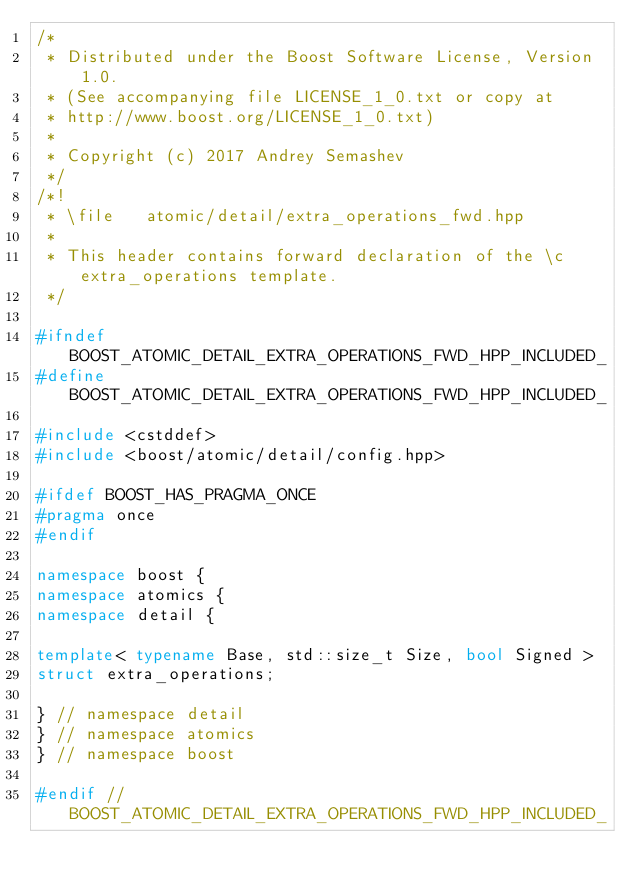Convert code to text. <code><loc_0><loc_0><loc_500><loc_500><_C++_>/*
 * Distributed under the Boost Software License, Version 1.0.
 * (See accompanying file LICENSE_1_0.txt or copy at
 * http://www.boost.org/LICENSE_1_0.txt)
 *
 * Copyright (c) 2017 Andrey Semashev
 */
/*!
 * \file   atomic/detail/extra_operations_fwd.hpp
 *
 * This header contains forward declaration of the \c extra_operations template.
 */

#ifndef BOOST_ATOMIC_DETAIL_EXTRA_OPERATIONS_FWD_HPP_INCLUDED_
#define BOOST_ATOMIC_DETAIL_EXTRA_OPERATIONS_FWD_HPP_INCLUDED_

#include <cstddef>
#include <boost/atomic/detail/config.hpp>

#ifdef BOOST_HAS_PRAGMA_ONCE
#pragma once
#endif

namespace boost {
namespace atomics {
namespace detail {

template< typename Base, std::size_t Size, bool Signed >
struct extra_operations;

} // namespace detail
} // namespace atomics
} // namespace boost

#endif // BOOST_ATOMIC_DETAIL_EXTRA_OPERATIONS_FWD_HPP_INCLUDED_
</code> 